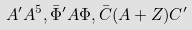Convert formula to latex. <formula><loc_0><loc_0><loc_500><loc_500>A ^ { \prime } A ^ { 5 } , \bar { \Phi } ^ { \prime } A \Phi , \bar { C } ( A + Z ) C ^ { \prime }</formula> 